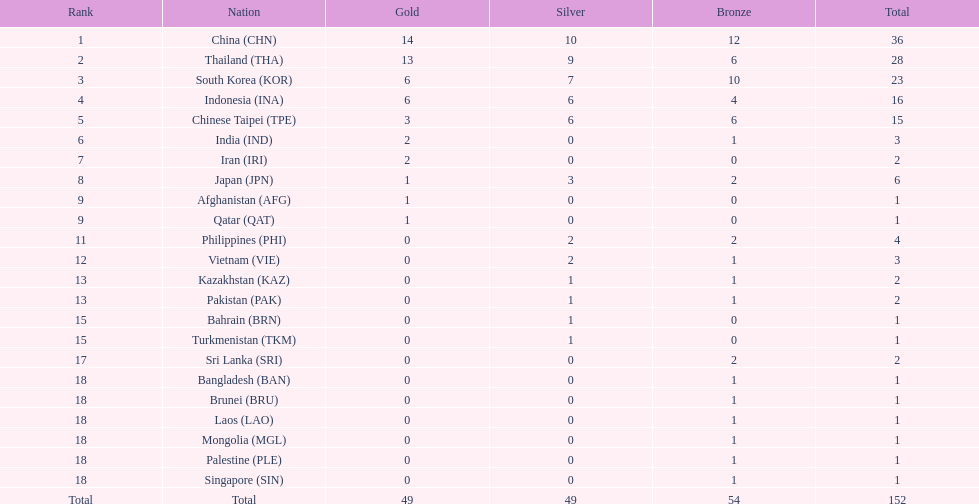Which country finished first in overall medals obtained? China (CHN). 